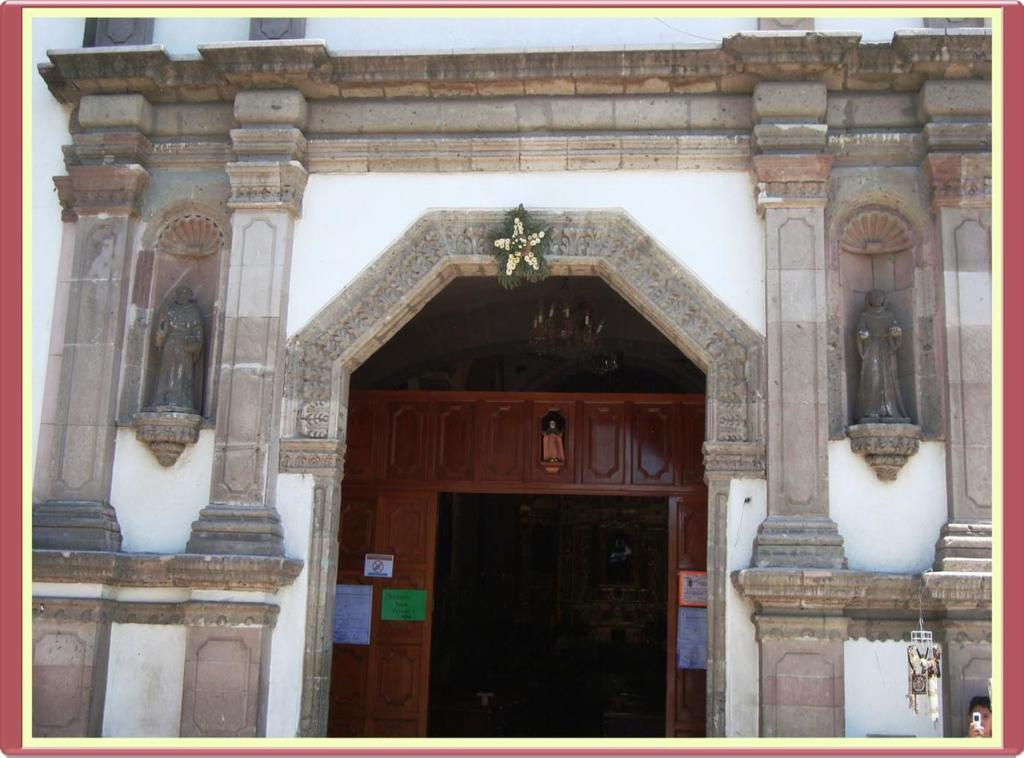What type: What architectural features are present in the image? There are pillars in the image. What is located in the middle of the image? There is a door in the middle of the image. What type of ornament is hanging from the door in the image? There is no ornament hanging from the door in the image; only the pillars and door are present. 